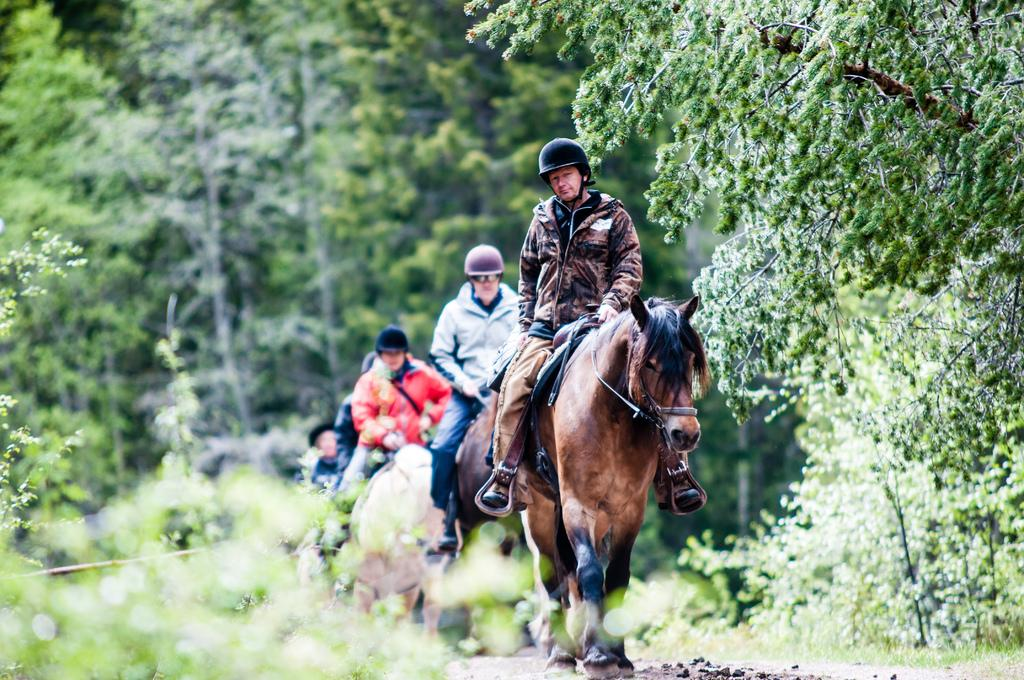What is the main subject of the image? There is a person riding a horse in the image. What is the person wearing on their head? The person is wearing a black helmet. What can be seen in the background of the image? There are trees and plants in the background of the image. What invention is being used by the person riding the horse in the image? There is no specific invention being used by the person riding the horse in the image; they are simply riding a horse. Can you tell me how many gates are visible in the image? There are no gates present in the image. 